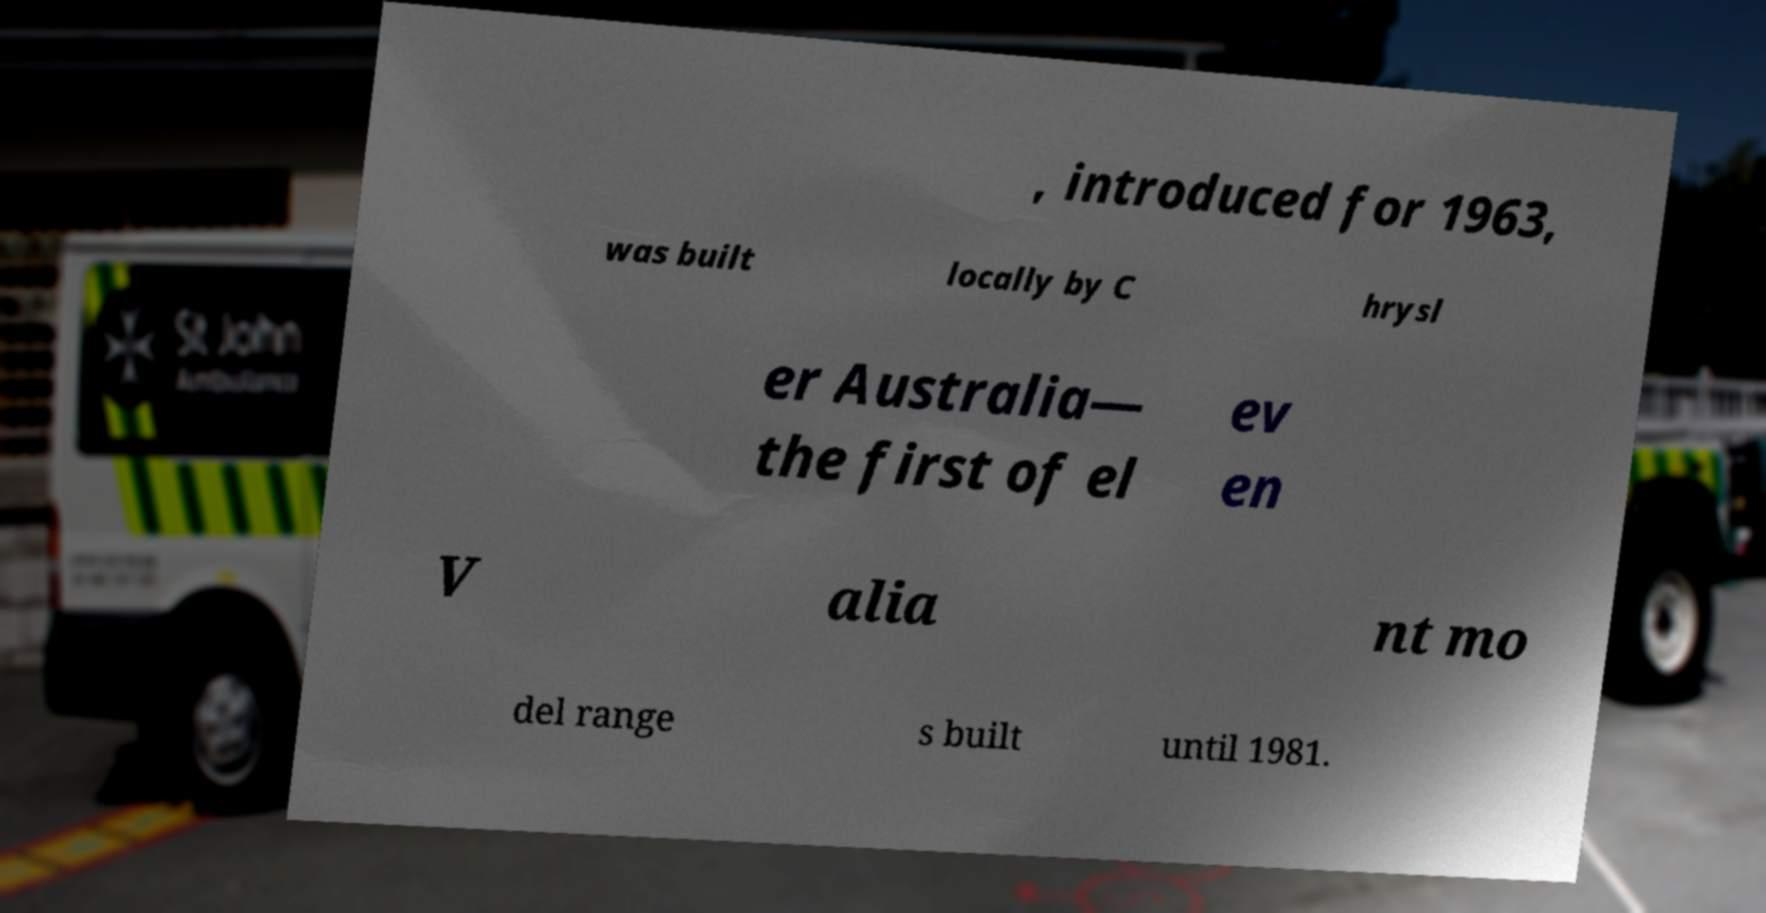For documentation purposes, I need the text within this image transcribed. Could you provide that? , introduced for 1963, was built locally by C hrysl er Australia— the first of el ev en V alia nt mo del range s built until 1981. 